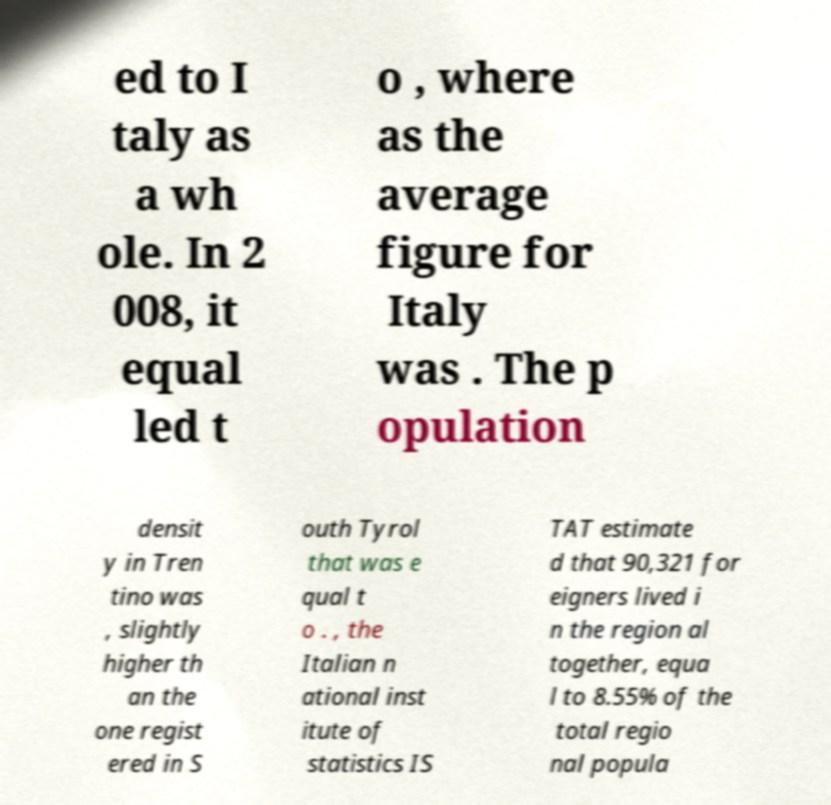Could you extract and type out the text from this image? ed to I taly as a wh ole. In 2 008, it equal led t o , where as the average figure for Italy was . The p opulation densit y in Tren tino was , slightly higher th an the one regist ered in S outh Tyrol that was e qual t o . , the Italian n ational inst itute of statistics IS TAT estimate d that 90,321 for eigners lived i n the region al together, equa l to 8.55% of the total regio nal popula 